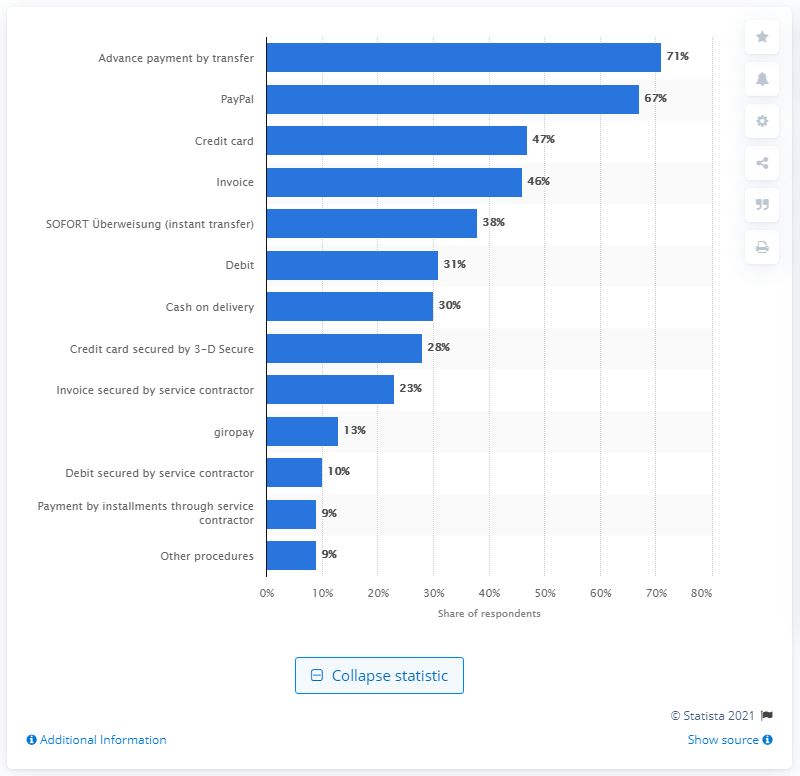Give some essential details in this illustration. In the online shops of 67% of companies, payment method was used the most, which was PayPal. 